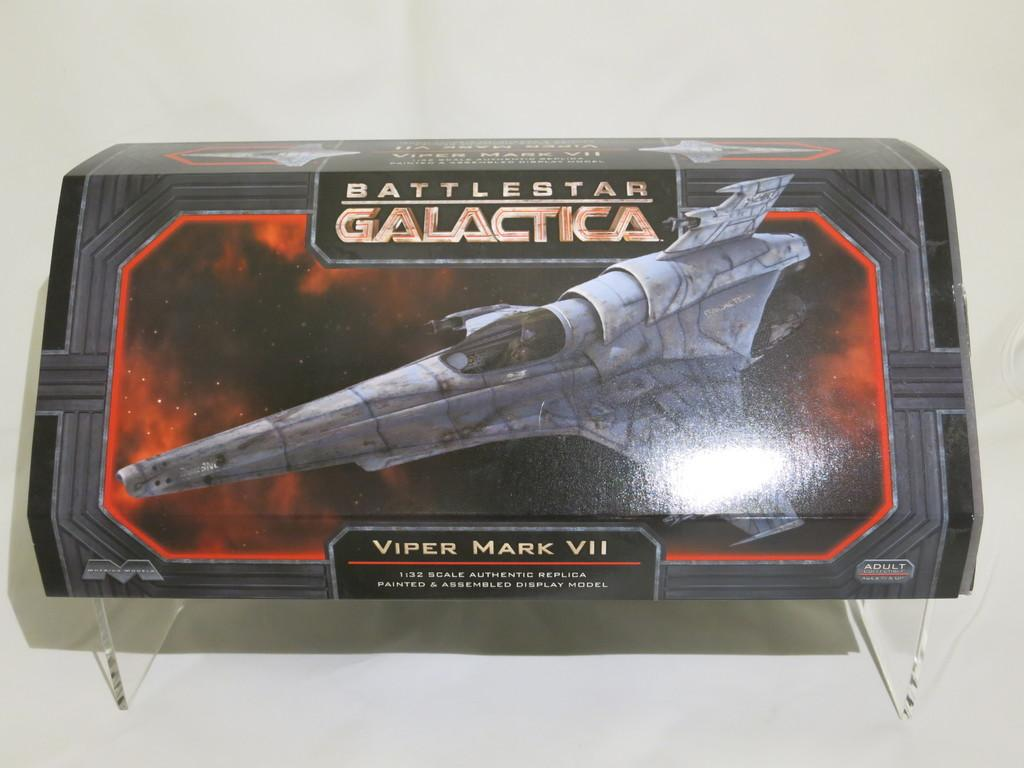<image>
Provide a brief description of the given image. a Battlestar Galactic Viper Mark VII jet toy in a box 